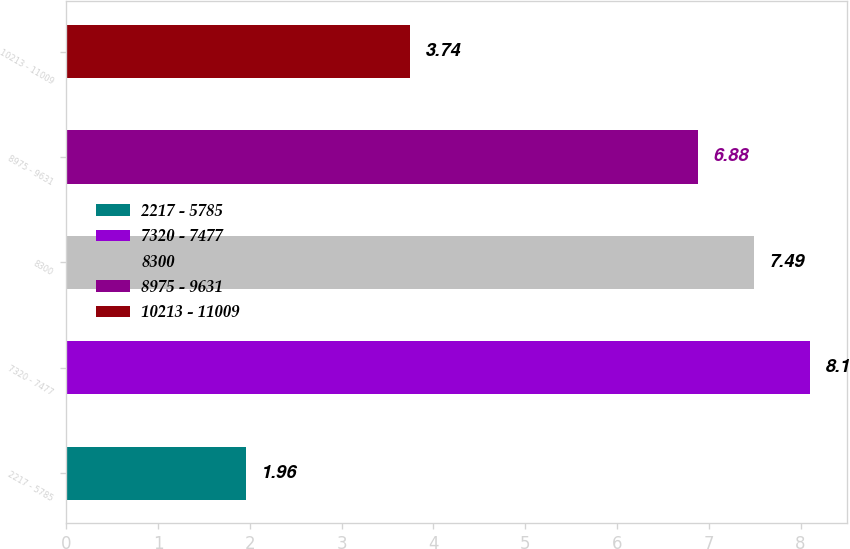Convert chart to OTSL. <chart><loc_0><loc_0><loc_500><loc_500><bar_chart><fcel>2217 - 5785<fcel>7320 - 7477<fcel>8300<fcel>8975 - 9631<fcel>10213 - 11009<nl><fcel>1.96<fcel>8.1<fcel>7.49<fcel>6.88<fcel>3.74<nl></chart> 